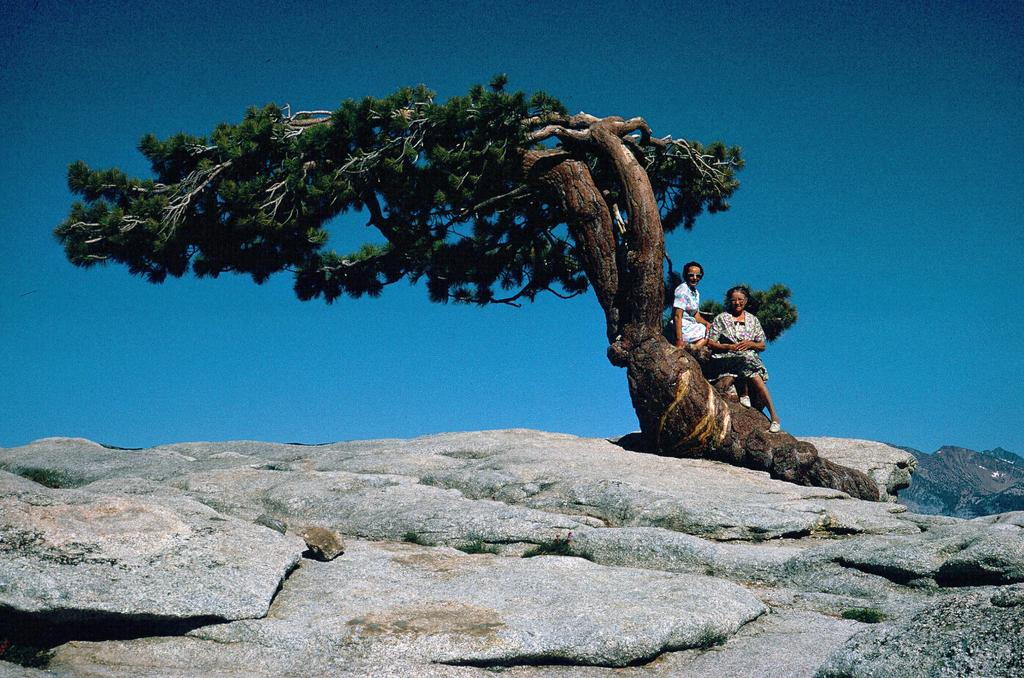What geographical feature is present in the image? There is a hill in the image. What can be found on the hill? There is a tree on the hill, and two ladies are sitting on the hill. What is visible in the background of the image? The sky is visible in the image. Is there a stream flowing down the hill in the image? No, there is no stream visible in the image. In which direction are the two ladies facing? The provided facts do not specify the direction the ladies are facing. 